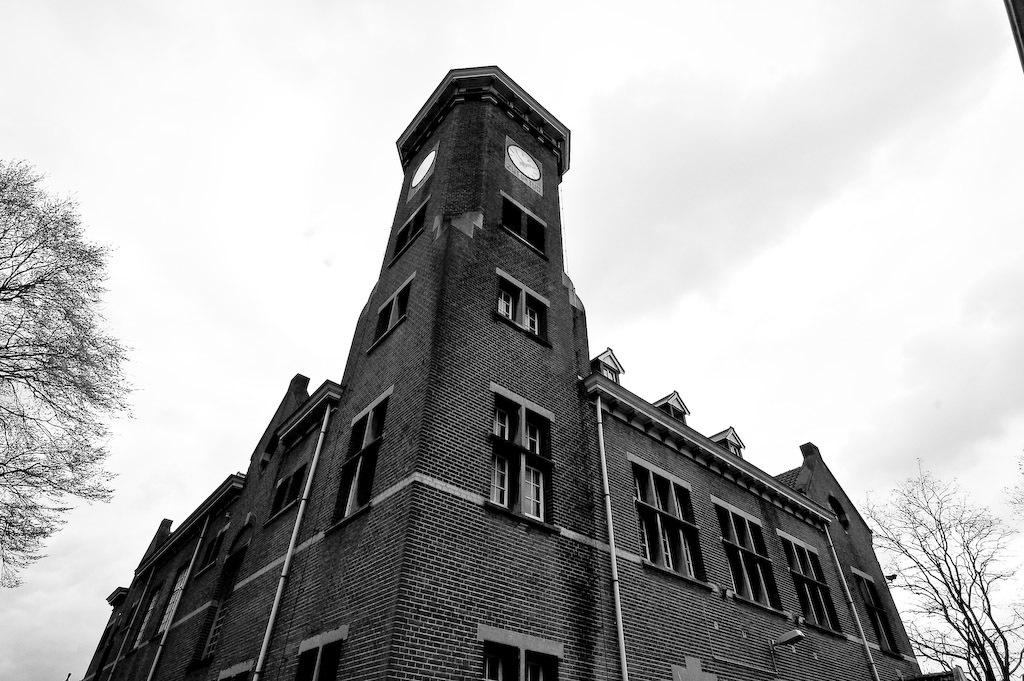What is the color scheme of the image? The image is black and white. What structure is present in the image? There is a building in the image. What features can be observed on the building? The building has windows, a roof, pipes, and a clock. What else is visible in the image besides the building? There are trees and the sky visible in the image. How would you describe the sky in the image? The sky appears cloudy in the image. Where is the worm crawling on the building in the image? There is no worm present in the image. What type of jewel can be seen on the clock in the image? There is no jewel present on the clock in the image. 